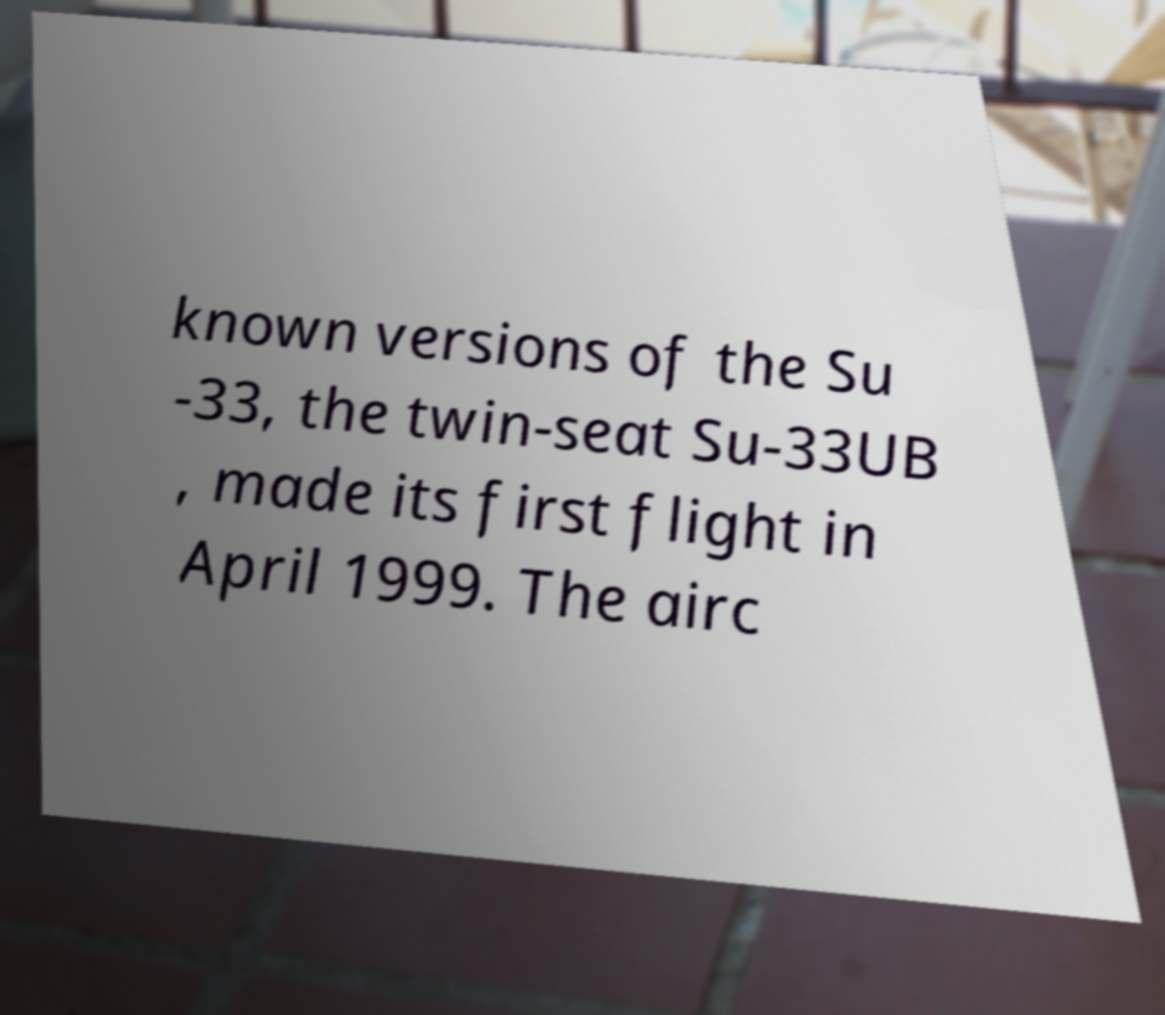There's text embedded in this image that I need extracted. Can you transcribe it verbatim? known versions of the Su -33, the twin-seat Su-33UB , made its first flight in April 1999. The airc 